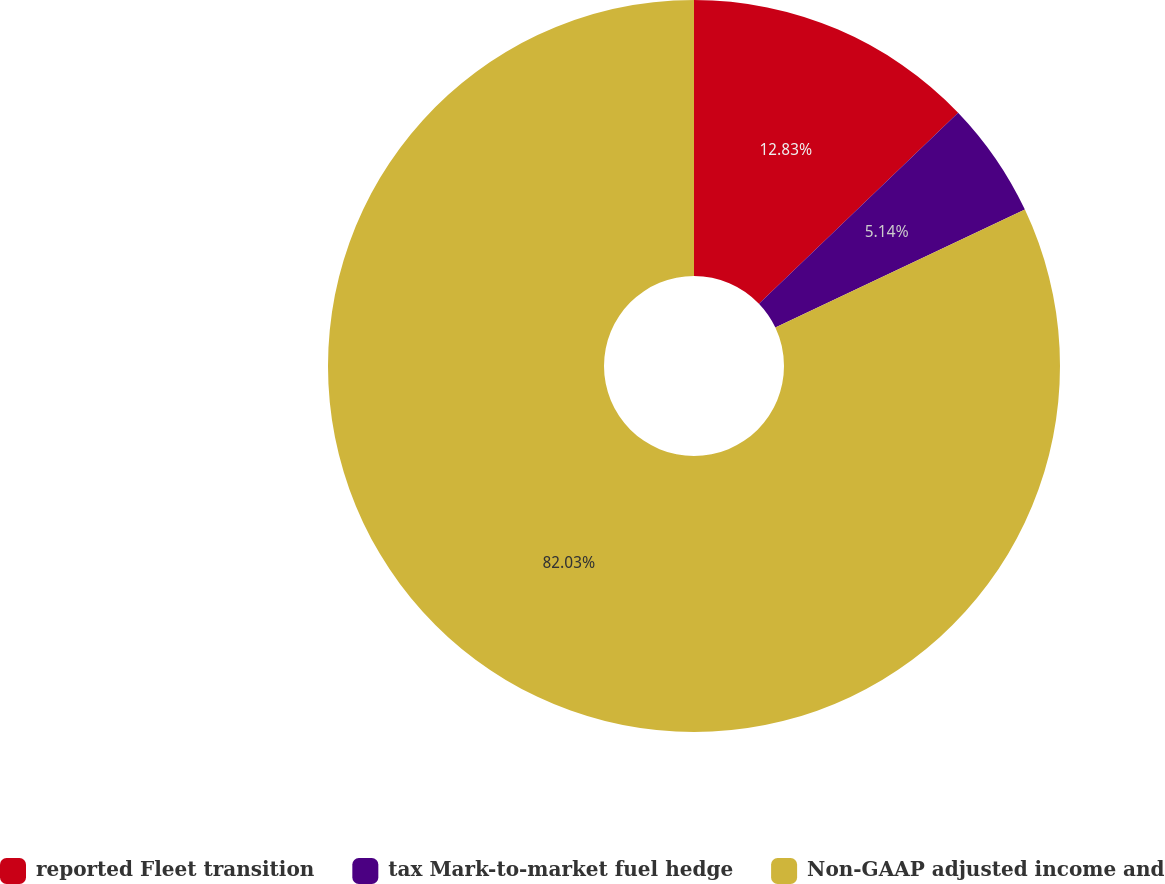Convert chart to OTSL. <chart><loc_0><loc_0><loc_500><loc_500><pie_chart><fcel>reported Fleet transition<fcel>tax Mark-to-market fuel hedge<fcel>Non-GAAP adjusted income and<nl><fcel>12.83%<fcel>5.14%<fcel>82.02%<nl></chart> 